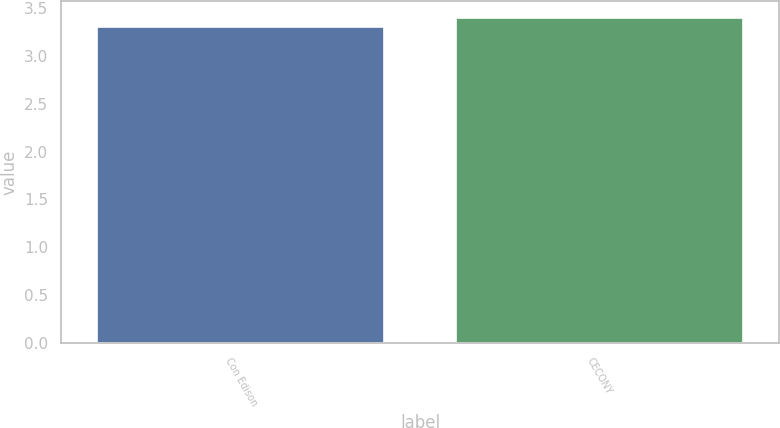Convert chart. <chart><loc_0><loc_0><loc_500><loc_500><bar_chart><fcel>Con Edison<fcel>CECONY<nl><fcel>3.3<fcel>3.4<nl></chart> 